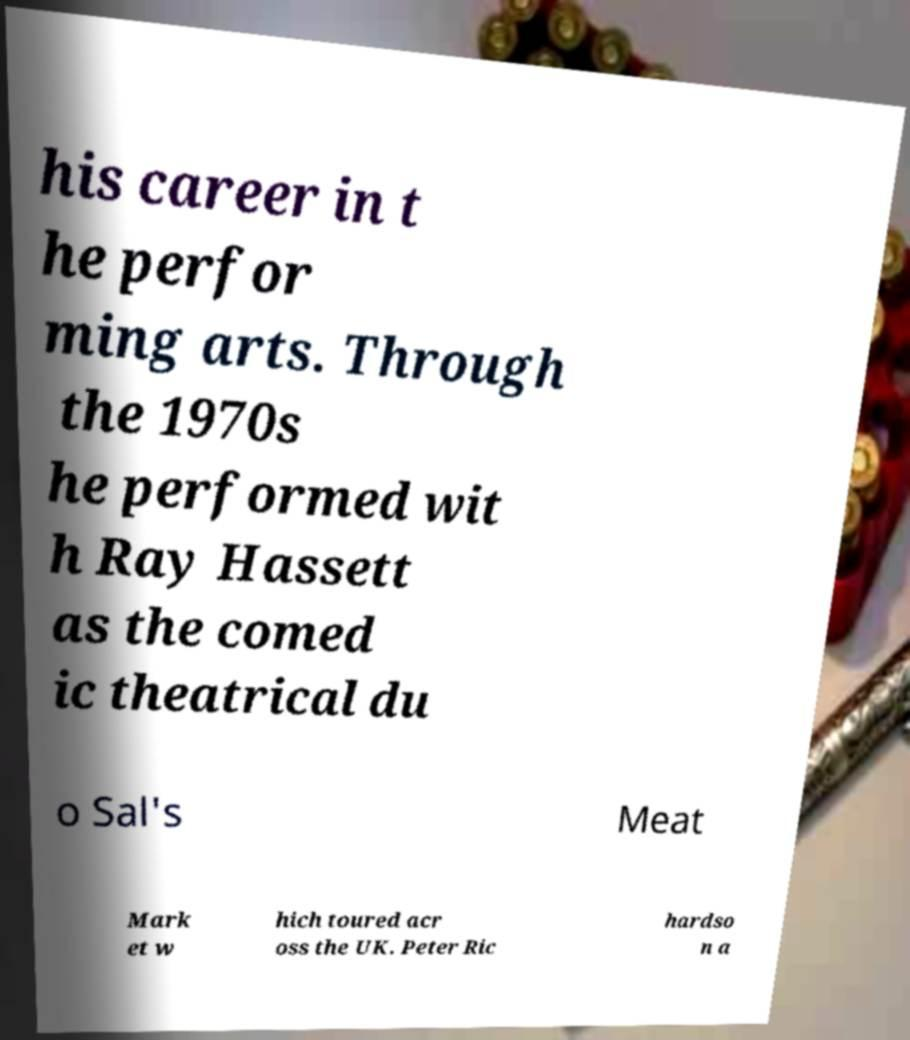What messages or text are displayed in this image? I need them in a readable, typed format. his career in t he perfor ming arts. Through the 1970s he performed wit h Ray Hassett as the comed ic theatrical du o Sal's Meat Mark et w hich toured acr oss the UK. Peter Ric hardso n a 